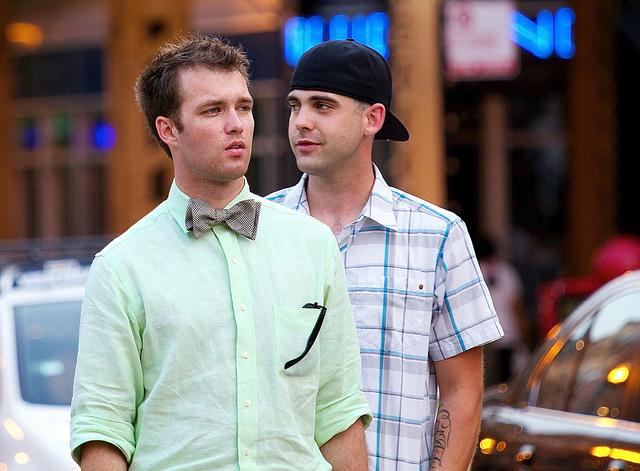What is the model of the white car?
Be succinct. Ford. What kind of tie is the man wearing?
Keep it brief. Bow tie. What is in the man's pocket?
Answer briefly. Glasses. 